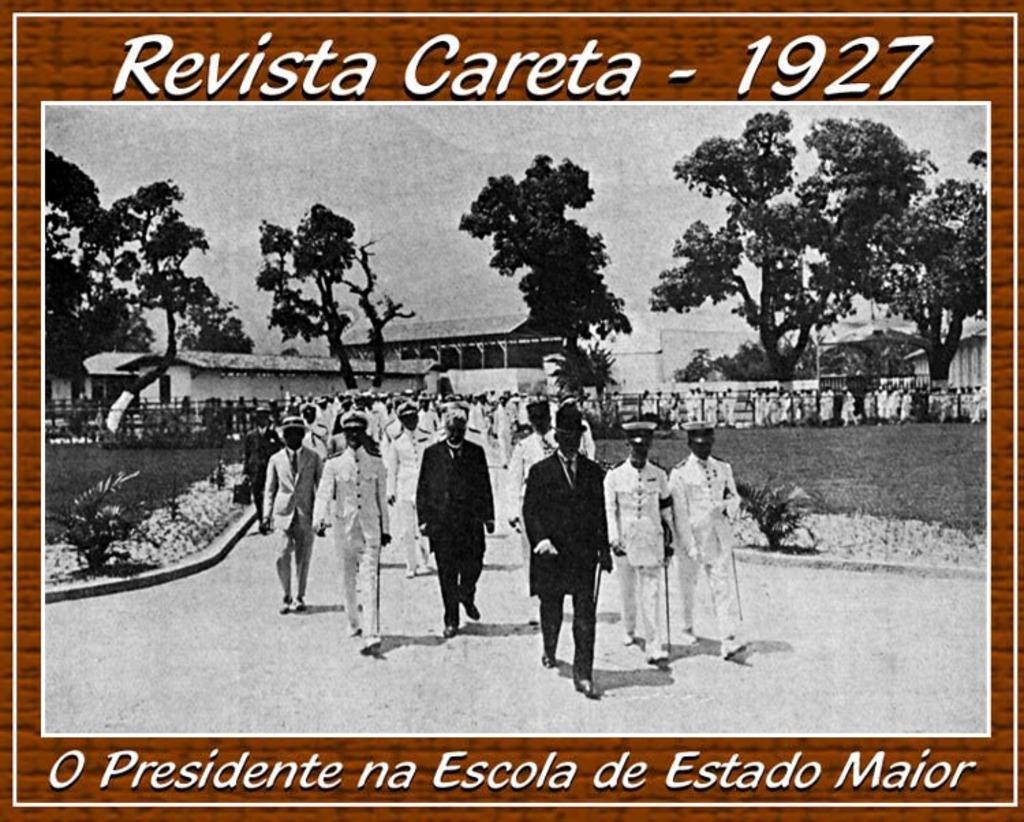What year is this photo in?
Make the answer very short. 1927. They are old memories?
Provide a succinct answer. Yes. 